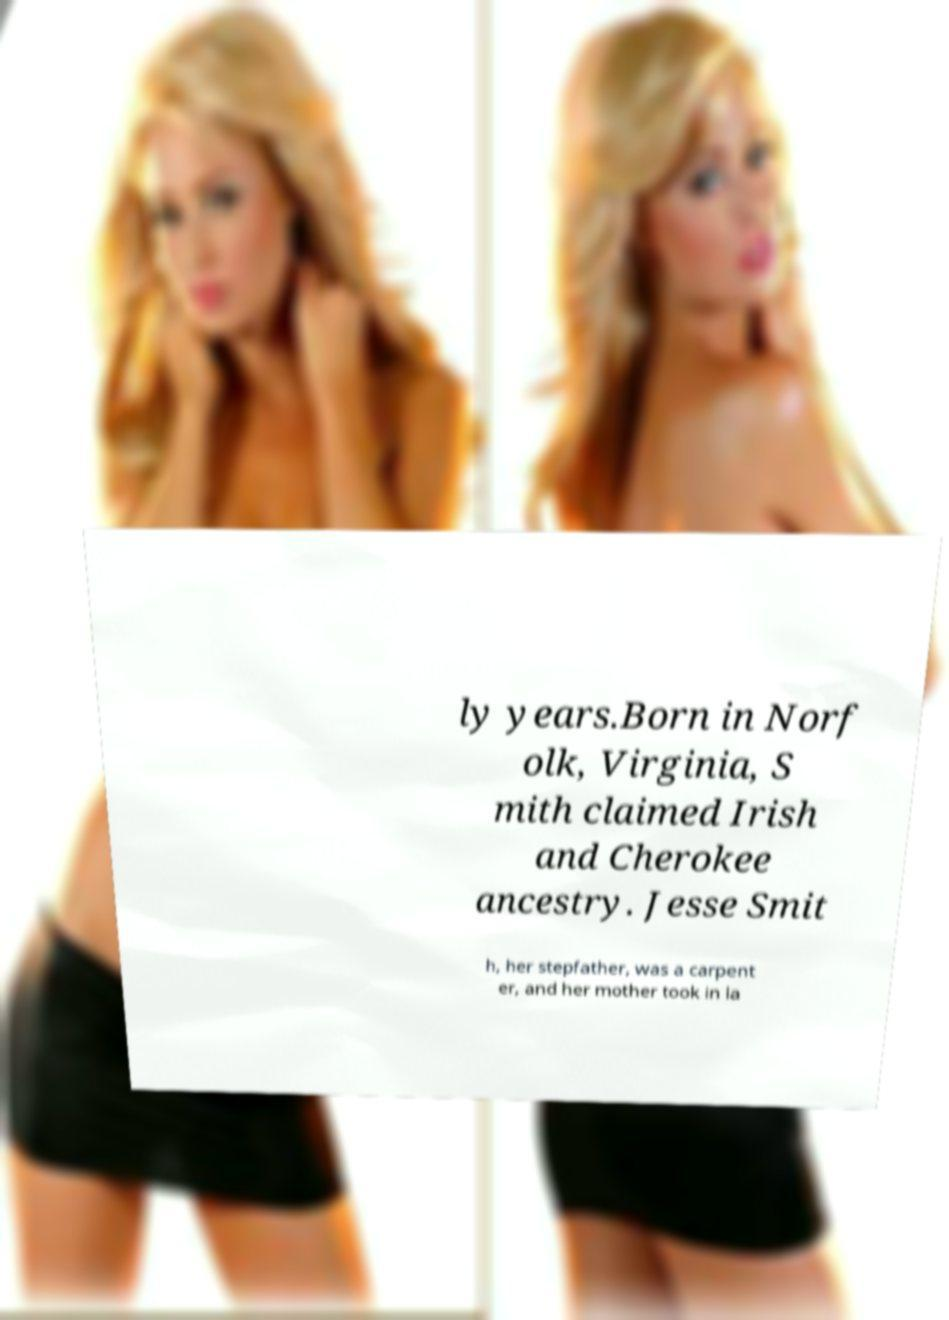Please identify and transcribe the text found in this image. ly years.Born in Norf olk, Virginia, S mith claimed Irish and Cherokee ancestry. Jesse Smit h, her stepfather, was a carpent er, and her mother took in la 